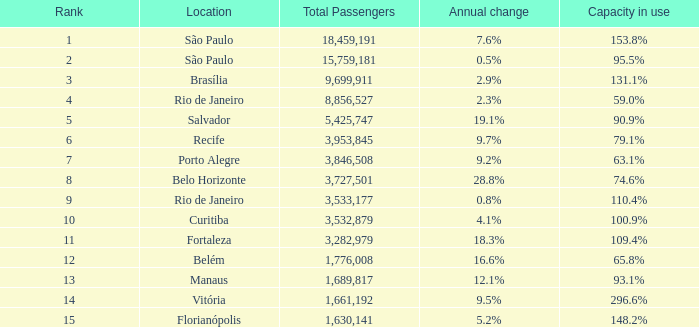7% and the ranking is less than 6? None. 